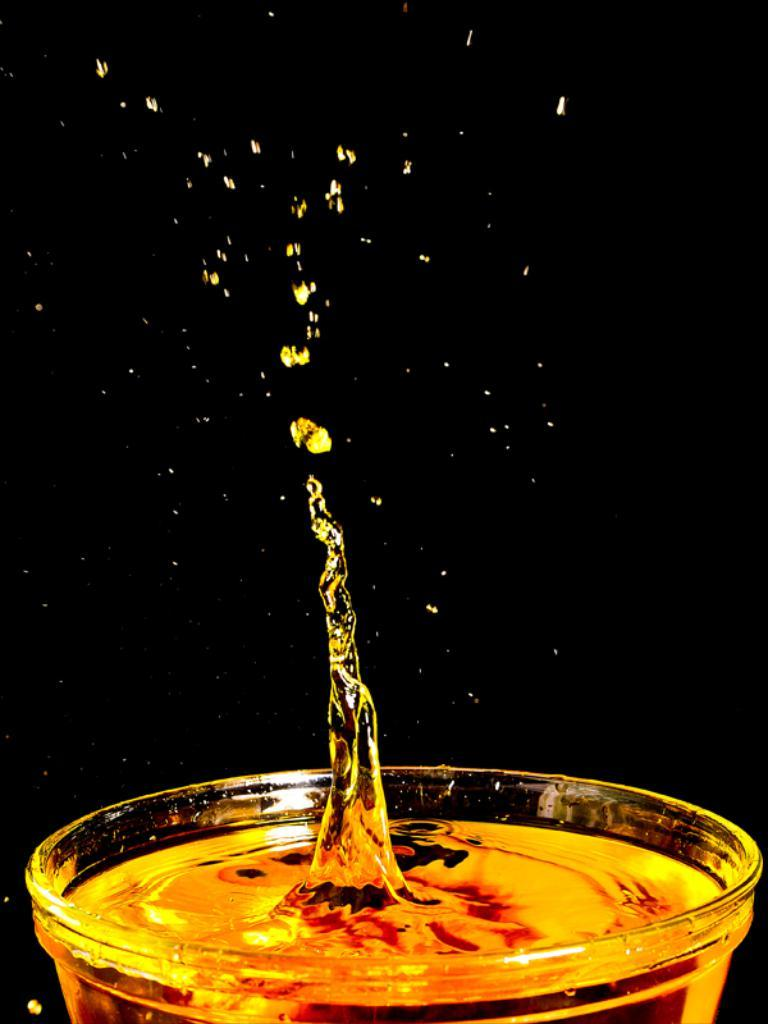What is contained in the glass in the image? There is liquid in a glass in the image. Can you describe the liquid in the glass? There are a few drops of liquid visible. What is the color of the background in the image? The background of the image is black in color. How many sisters are visible in the image while the boy is reading? There are no sisters or boys present in the image, nor is anyone reading. 